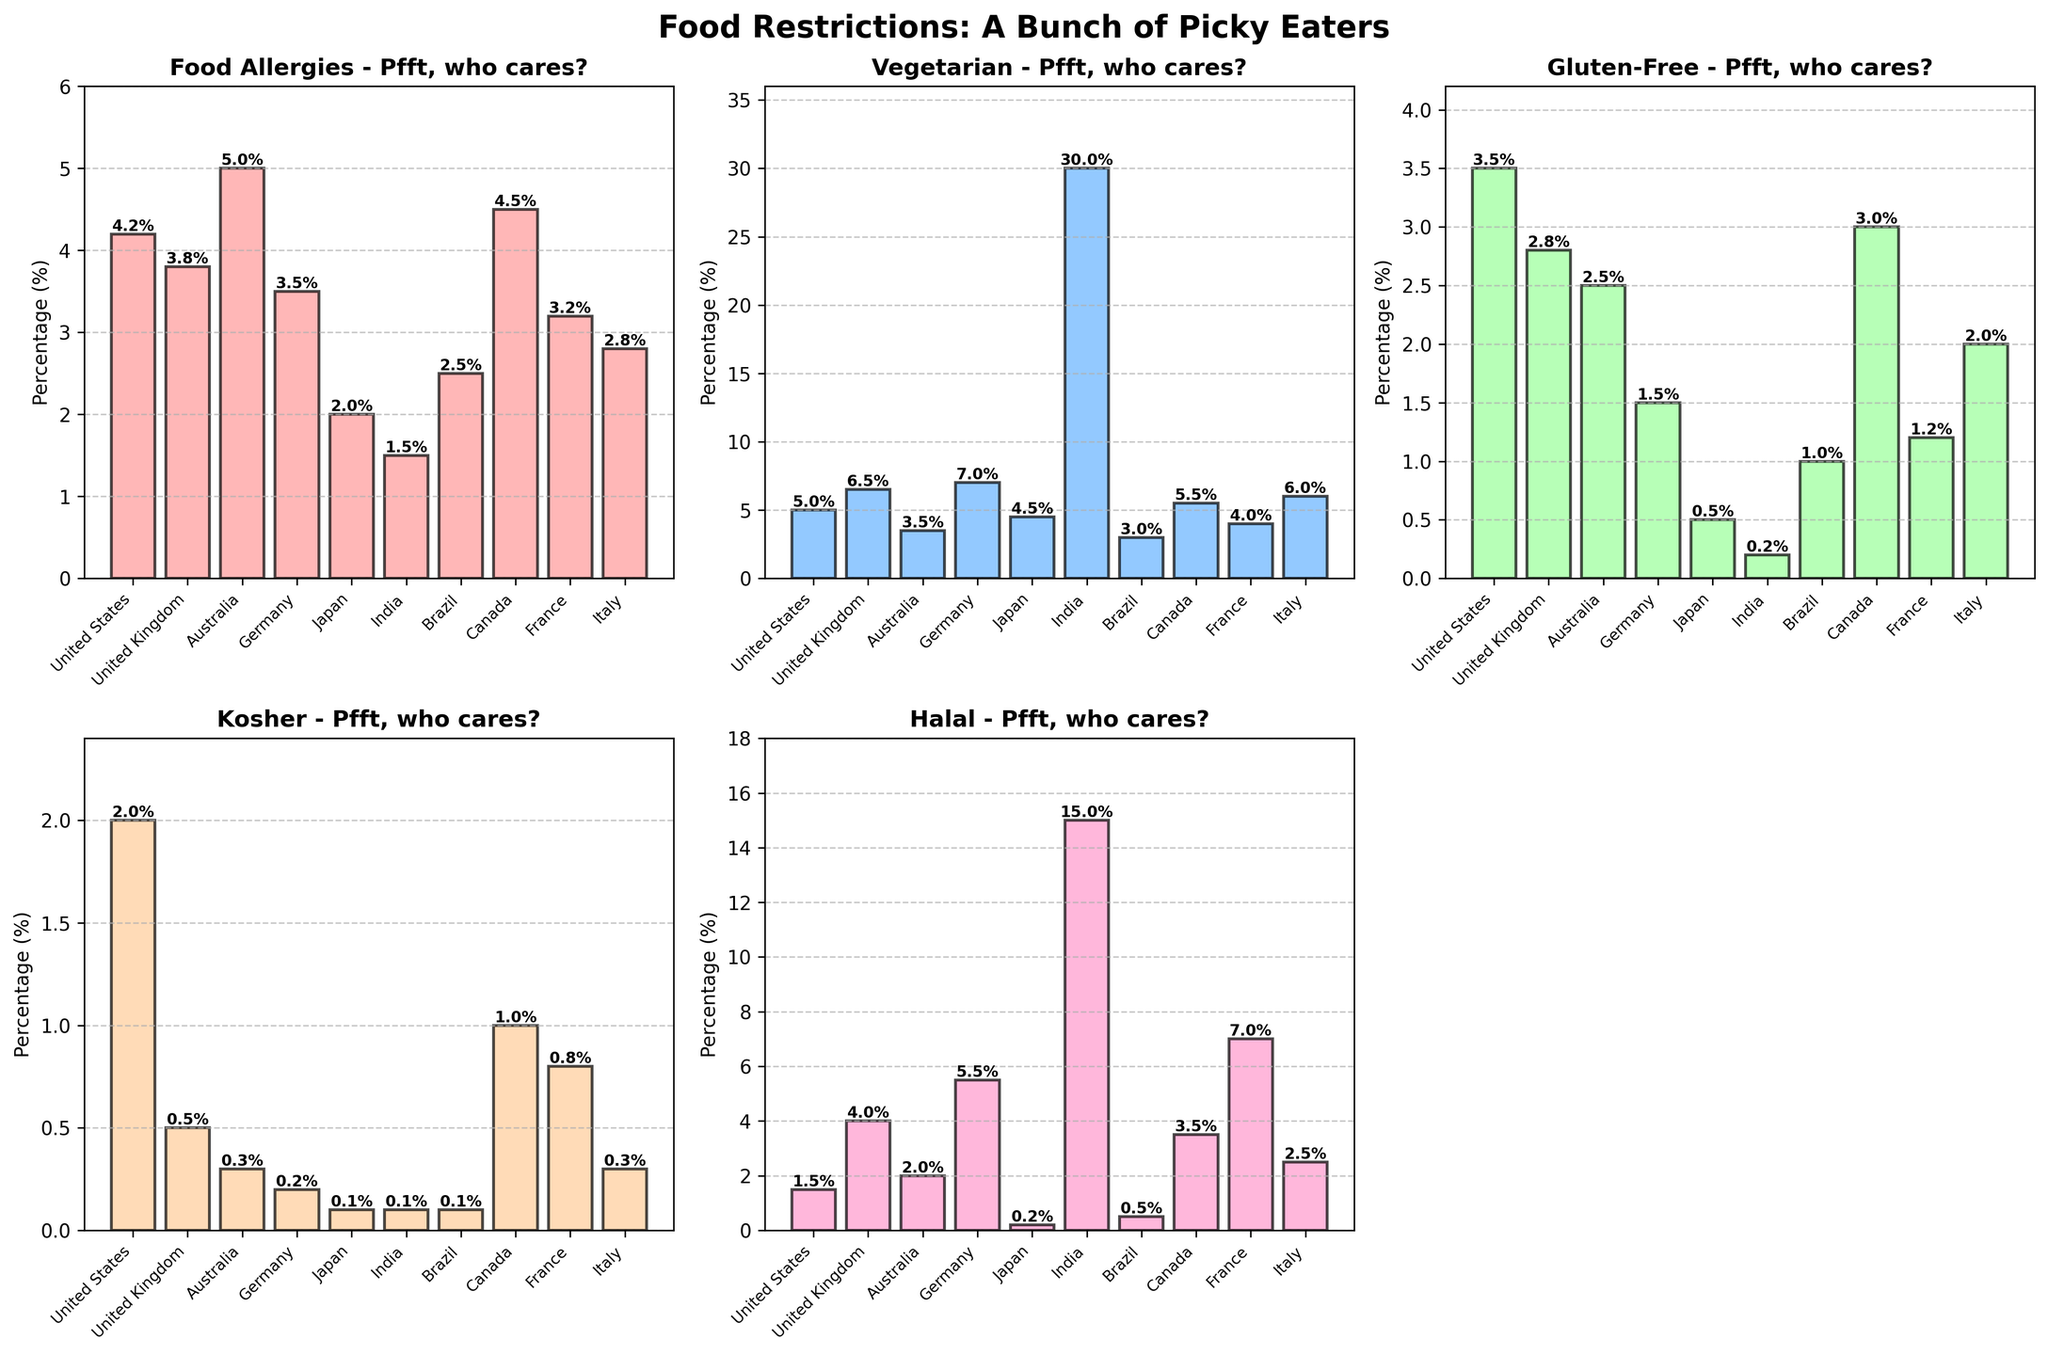What is the title of the figure? The title can be found at the very top of the figure and summarizes the overall content of the chart.
Answer: Food Restrictions: A Bunch of Picky Eaters Which dietary restriction has the highest percentage in India? Look at the bars corresponding to India in each subplot and find the one with the highest value.
Answer: Vegetarian Which country has the lowest prevalence of nut allergies (Food Allergies)? Examine the 'Food Allergies' subplot, and identify the bar with the smallest length. Each bar is labeled by country.
Answer: India How do the percentages of vegetarians in Germany compare to those in Italy? Look at the 'Vegetarian' subplot, observe the height of the bars labeled 'Germany' and 'Italy', and compare their heights.
Answer: Germany has a higher percentage What is the combined percentage of people with food allergies and those who follow a gluten-free diet in Canada? Sum the heights of the bars for 'Food Allergies' and 'Gluten-Free' in the Canada section of their respective subplots.
Answer: 4.5% + 3.0% = 7.5% Which country has the largest difference between halal and kosher percentages? Look at the 'Halal' and 'Kosher' subplots, calculate the difference between these two values for each country, and identify the largest difference.
Answer: France (7.0% difference) What is the total percentage for vegetarian dietary restriction across all countries? Add up the percentages for 'Vegetarian' from each country’s bar in the 'Vegetarian' subplot.
Answer: 4.2 + 6.5 + 3.5 + 7.0 + 4.5 + 30.0 + 3.0 + 5.5 + 4.0 + 6.0 = 74.2% Which countries have more people with food allergies than vegetarians? Compare the heights of the 'Food Allergies' and 'Vegetarian' bars for each country and list those where 'Food Allergies' bars are taller.
Answer: Australia What's the average percentage of gluten-free dietary restriction for the countries with more than 5% vegetarians? Identify the countries with 'Vegetarian' bars greater than 5%, then calculate the average percentage of 'Gluten-Free' for these countries.
Answer: (2.8 + 3.0) / 2 = 2.9% Which country has the highest average percentage among food allergies, kosher, and halal? Calculate the average percentage (sum the percentages and divide by 3) of 'Food Allergies', 'Kosher', and 'Halal' for each country and identify the highest one.
Answer: Germany (3.5 + 0.2 + 5.5) / 3 = 3.07, highest value 